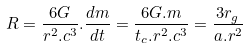Convert formula to latex. <formula><loc_0><loc_0><loc_500><loc_500>R = { \frac { 6 G } { { r ^ { 2 } . c ^ { 3 } } } } . { \frac { d m } { d t } } = { \frac { 6 G . m } { { t _ { c } . r ^ { 2 } . c ^ { 3 } } } } = { \frac { { 3 r _ { g } } } { { a . r ^ { 2 } } } }</formula> 